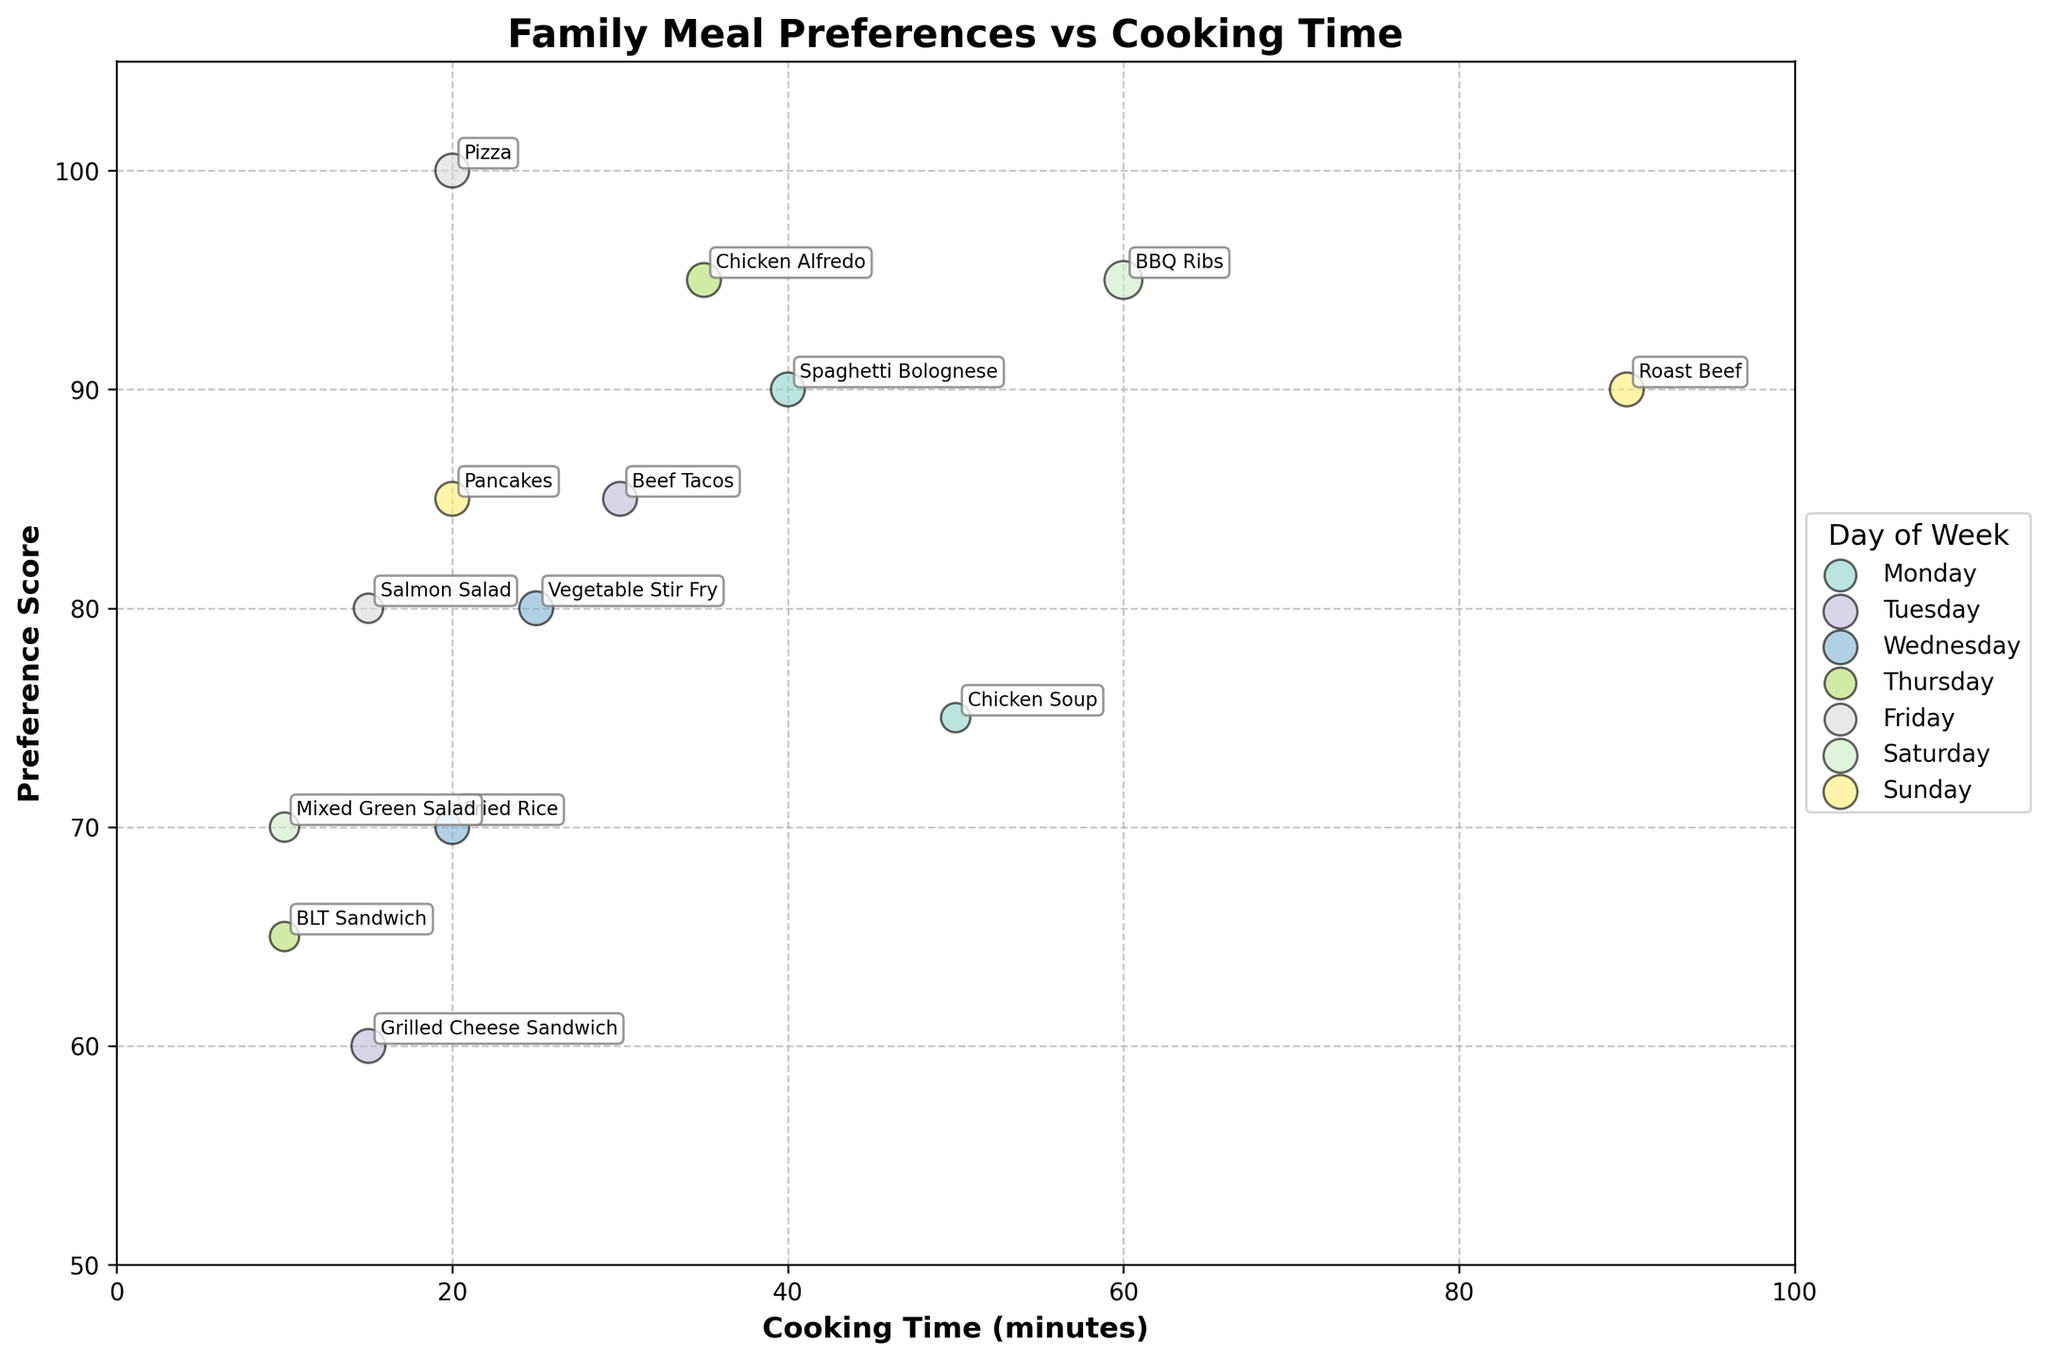What day has the highest preference score for a meal? Look for the meal with the highest y-value (Preference Score) on the chart and identify the corresponding day.
Answer: Friday What is the cooking time for BBQ Ribs on Saturday? Locate "BBQ Ribs" on the chart and read the corresponding value on the x-axis (Cooking Time).
Answer: 60 minutes Which day has the most meals preferred by 4 family members? Count the bubbles with a size corresponding to 4 family members (larger bubbles) for each day and determine the day with the most of such bubbles.
Answer: Wednesday What is the range of cooking times for meals on Thursday? Find the minimum and maximum cooking times for meals on Thursday and subtract the minimum from the maximum. Look at the values on the x-axis for the meals on Thursday.
Answer: 25 minutes (35 - 10) Which meal has a higher preference score, Chicken Alfredo or Fried Rice? Identify the y-values (Preference Scores) for Chicken Alfredo and Fried Rice on the chart and compare them.
Answer: Chicken Alfredo How many minutes longer does it take to cook Chicken Soup compared to BLT Sandwich? Subtract the Cooking Time of BLT Sandwich from Chicken Soup by reading their values on the x-axis.
Answer: 40 minutes Which day has the most diverse cooking times? Count the distinct x-values (Cooking Times) for each day and find the day with the highest count.
Answer: Sunday What is the average cooking time for meals on Monday? Add the cooking times for all meals on Monday and divide by the number of meals. Calculate as: (40 + 50) / 2 = 45.
Answer: 45 minutes Which meal has the smallest bubble size on Tuesday? Identify the meal with the smallest size bubble on Tuesday using visual inspection of bubble sizes.
Answer: Grilled Cheese Sandwich Which meal on Saturday has a higher preference score, BBQ Ribs or Mixed Green Salad? Identify the y-values (Preference Scores) for BBQ Ribs and Mixed Green Salad on the chart and compare them.
Answer: BBQ Ribs 